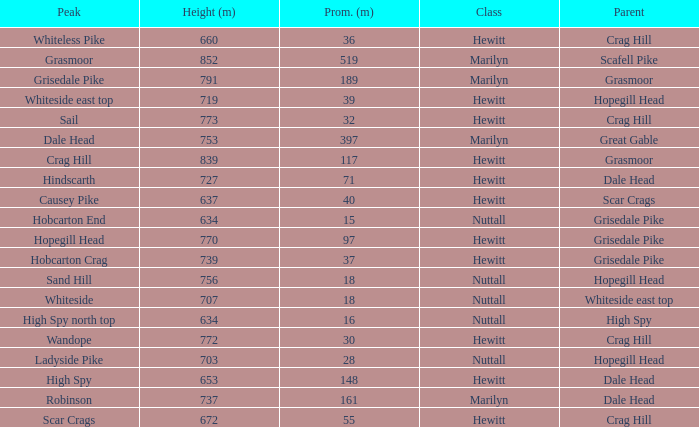What is the lowest height for Parent grasmoor when it has a Prom larger than 117? 791.0. 